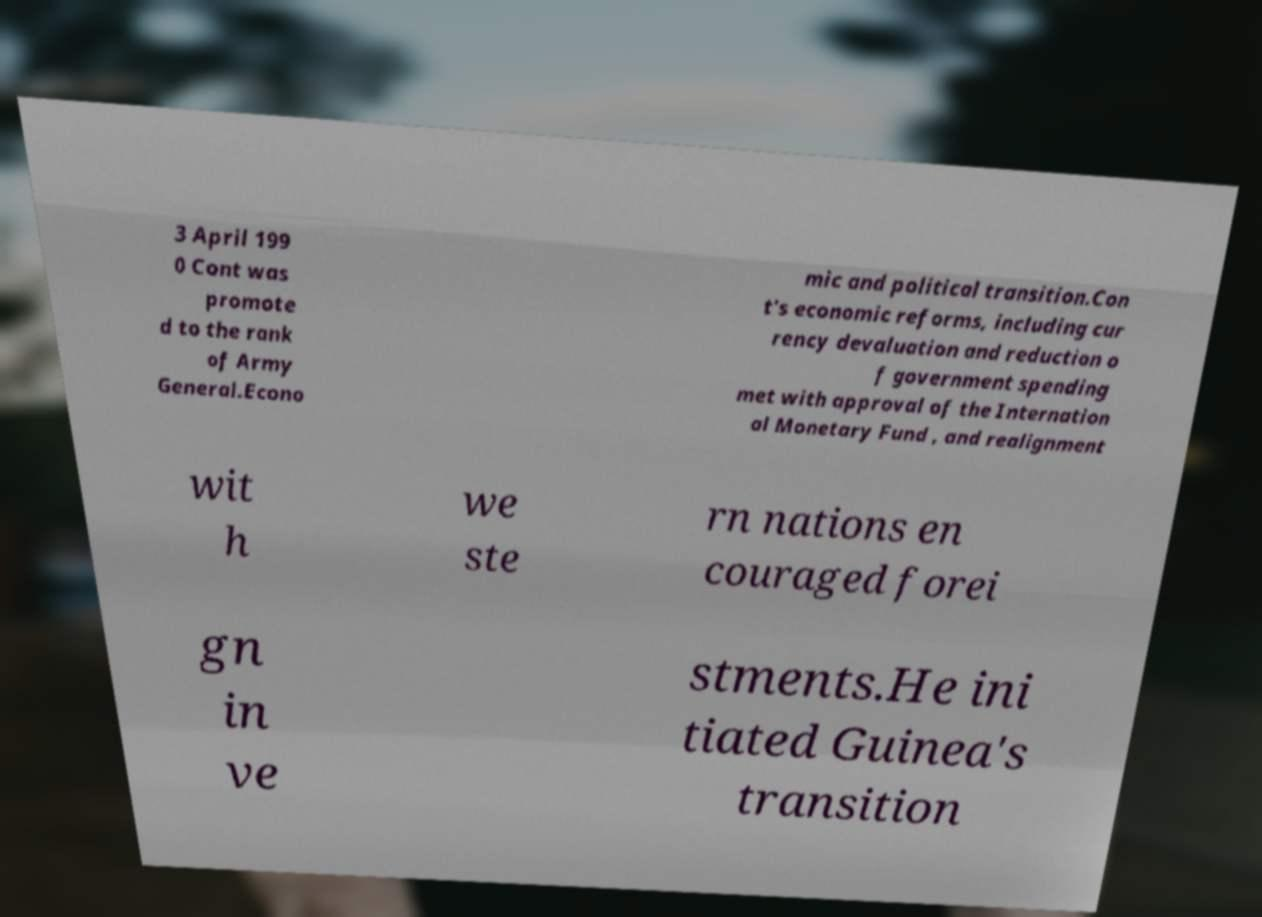Please read and relay the text visible in this image. What does it say? 3 April 199 0 Cont was promote d to the rank of Army General.Econo mic and political transition.Con t's economic reforms, including cur rency devaluation and reduction o f government spending met with approval of the Internation al Monetary Fund , and realignment wit h we ste rn nations en couraged forei gn in ve stments.He ini tiated Guinea's transition 